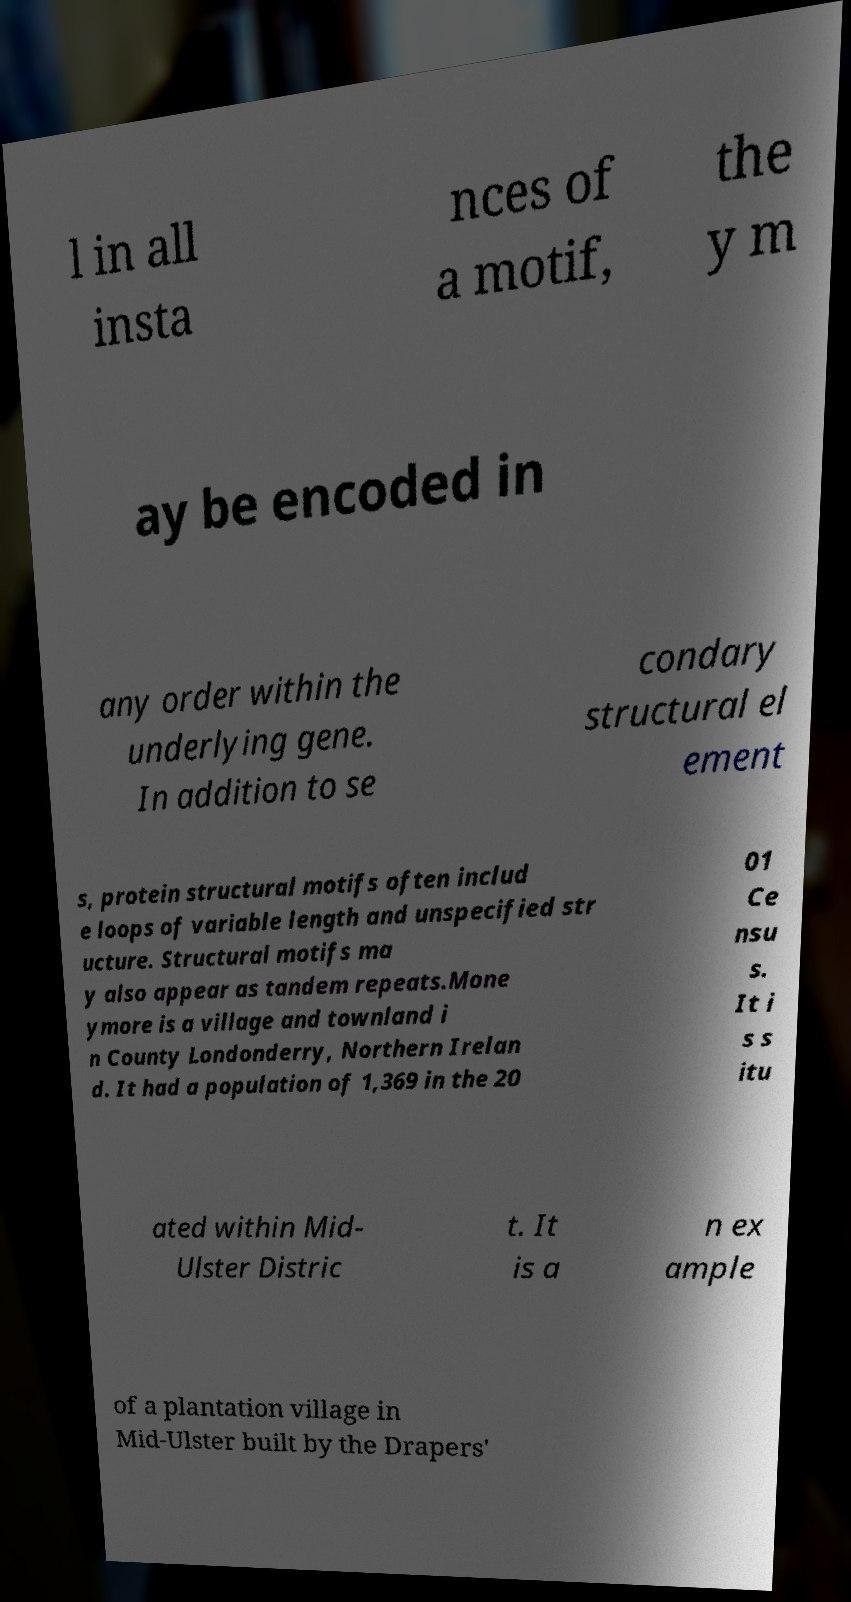Please read and relay the text visible in this image. What does it say? l in all insta nces of a motif, the y m ay be encoded in any order within the underlying gene. In addition to se condary structural el ement s, protein structural motifs often includ e loops of variable length and unspecified str ucture. Structural motifs ma y also appear as tandem repeats.Mone ymore is a village and townland i n County Londonderry, Northern Irelan d. It had a population of 1,369 in the 20 01 Ce nsu s. It i s s itu ated within Mid- Ulster Distric t. It is a n ex ample of a plantation village in Mid-Ulster built by the Drapers' 